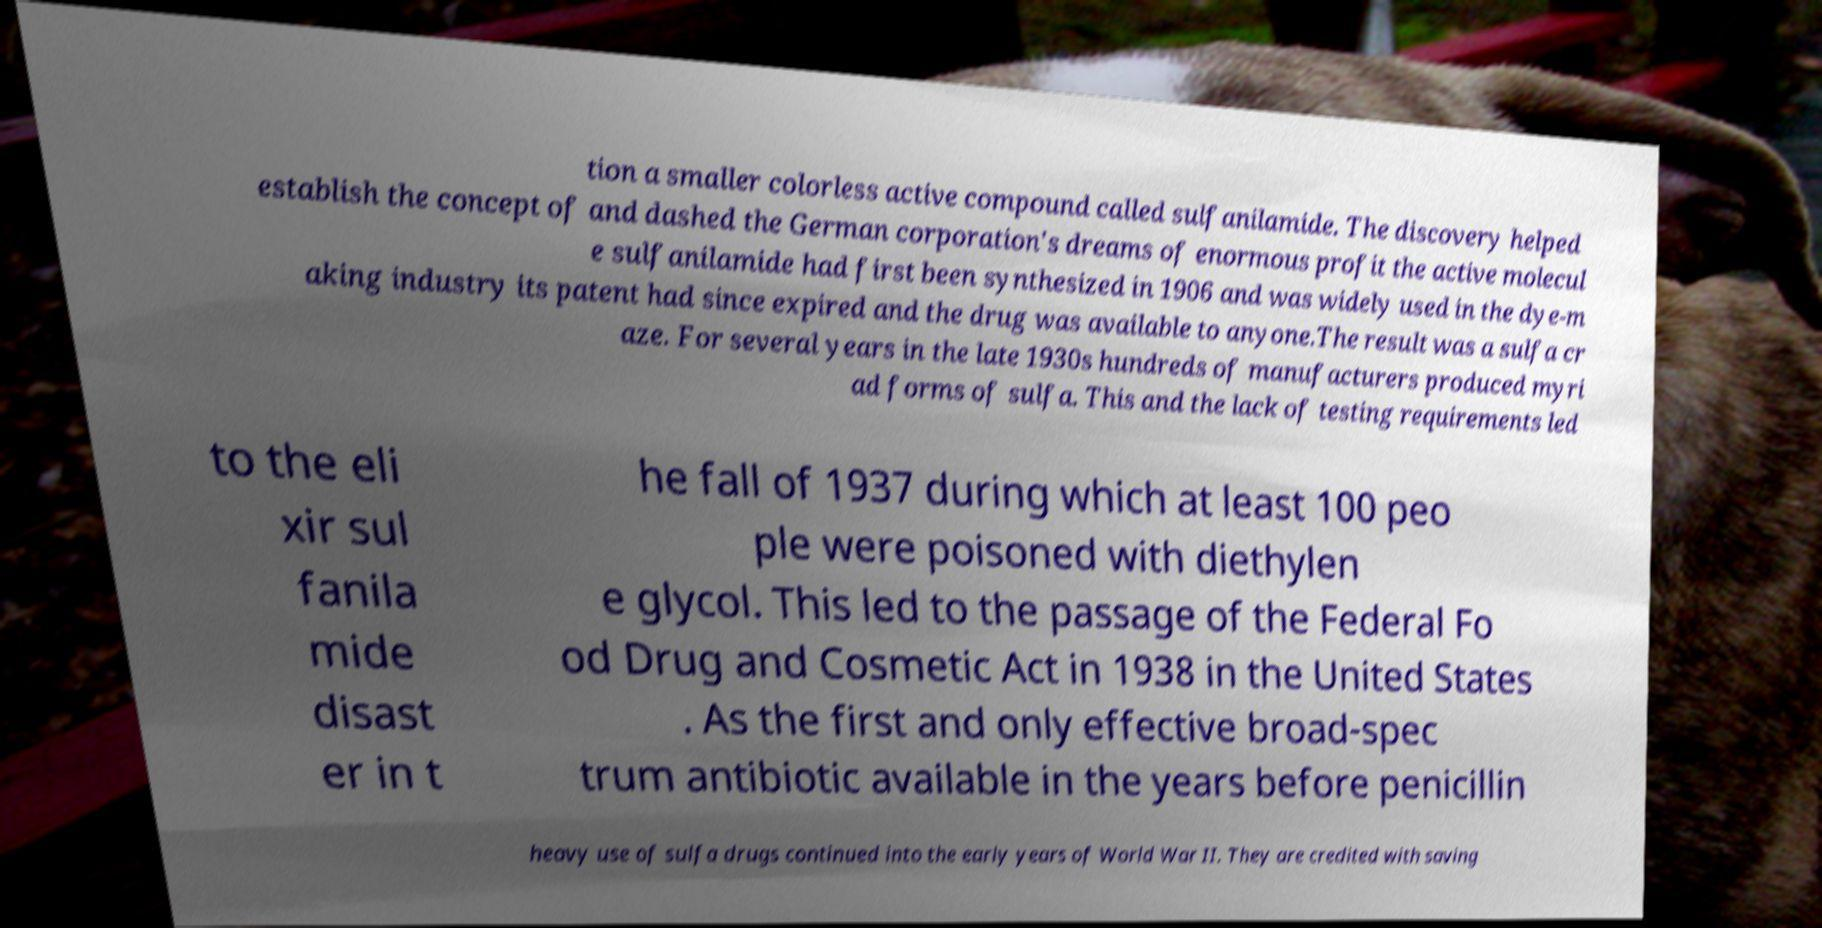There's text embedded in this image that I need extracted. Can you transcribe it verbatim? tion a smaller colorless active compound called sulfanilamide. The discovery helped establish the concept of and dashed the German corporation's dreams of enormous profit the active molecul e sulfanilamide had first been synthesized in 1906 and was widely used in the dye-m aking industry its patent had since expired and the drug was available to anyone.The result was a sulfa cr aze. For several years in the late 1930s hundreds of manufacturers produced myri ad forms of sulfa. This and the lack of testing requirements led to the eli xir sul fanila mide disast er in t he fall of 1937 during which at least 100 peo ple were poisoned with diethylen e glycol. This led to the passage of the Federal Fo od Drug and Cosmetic Act in 1938 in the United States . As the first and only effective broad-spec trum antibiotic available in the years before penicillin heavy use of sulfa drugs continued into the early years of World War II. They are credited with saving 